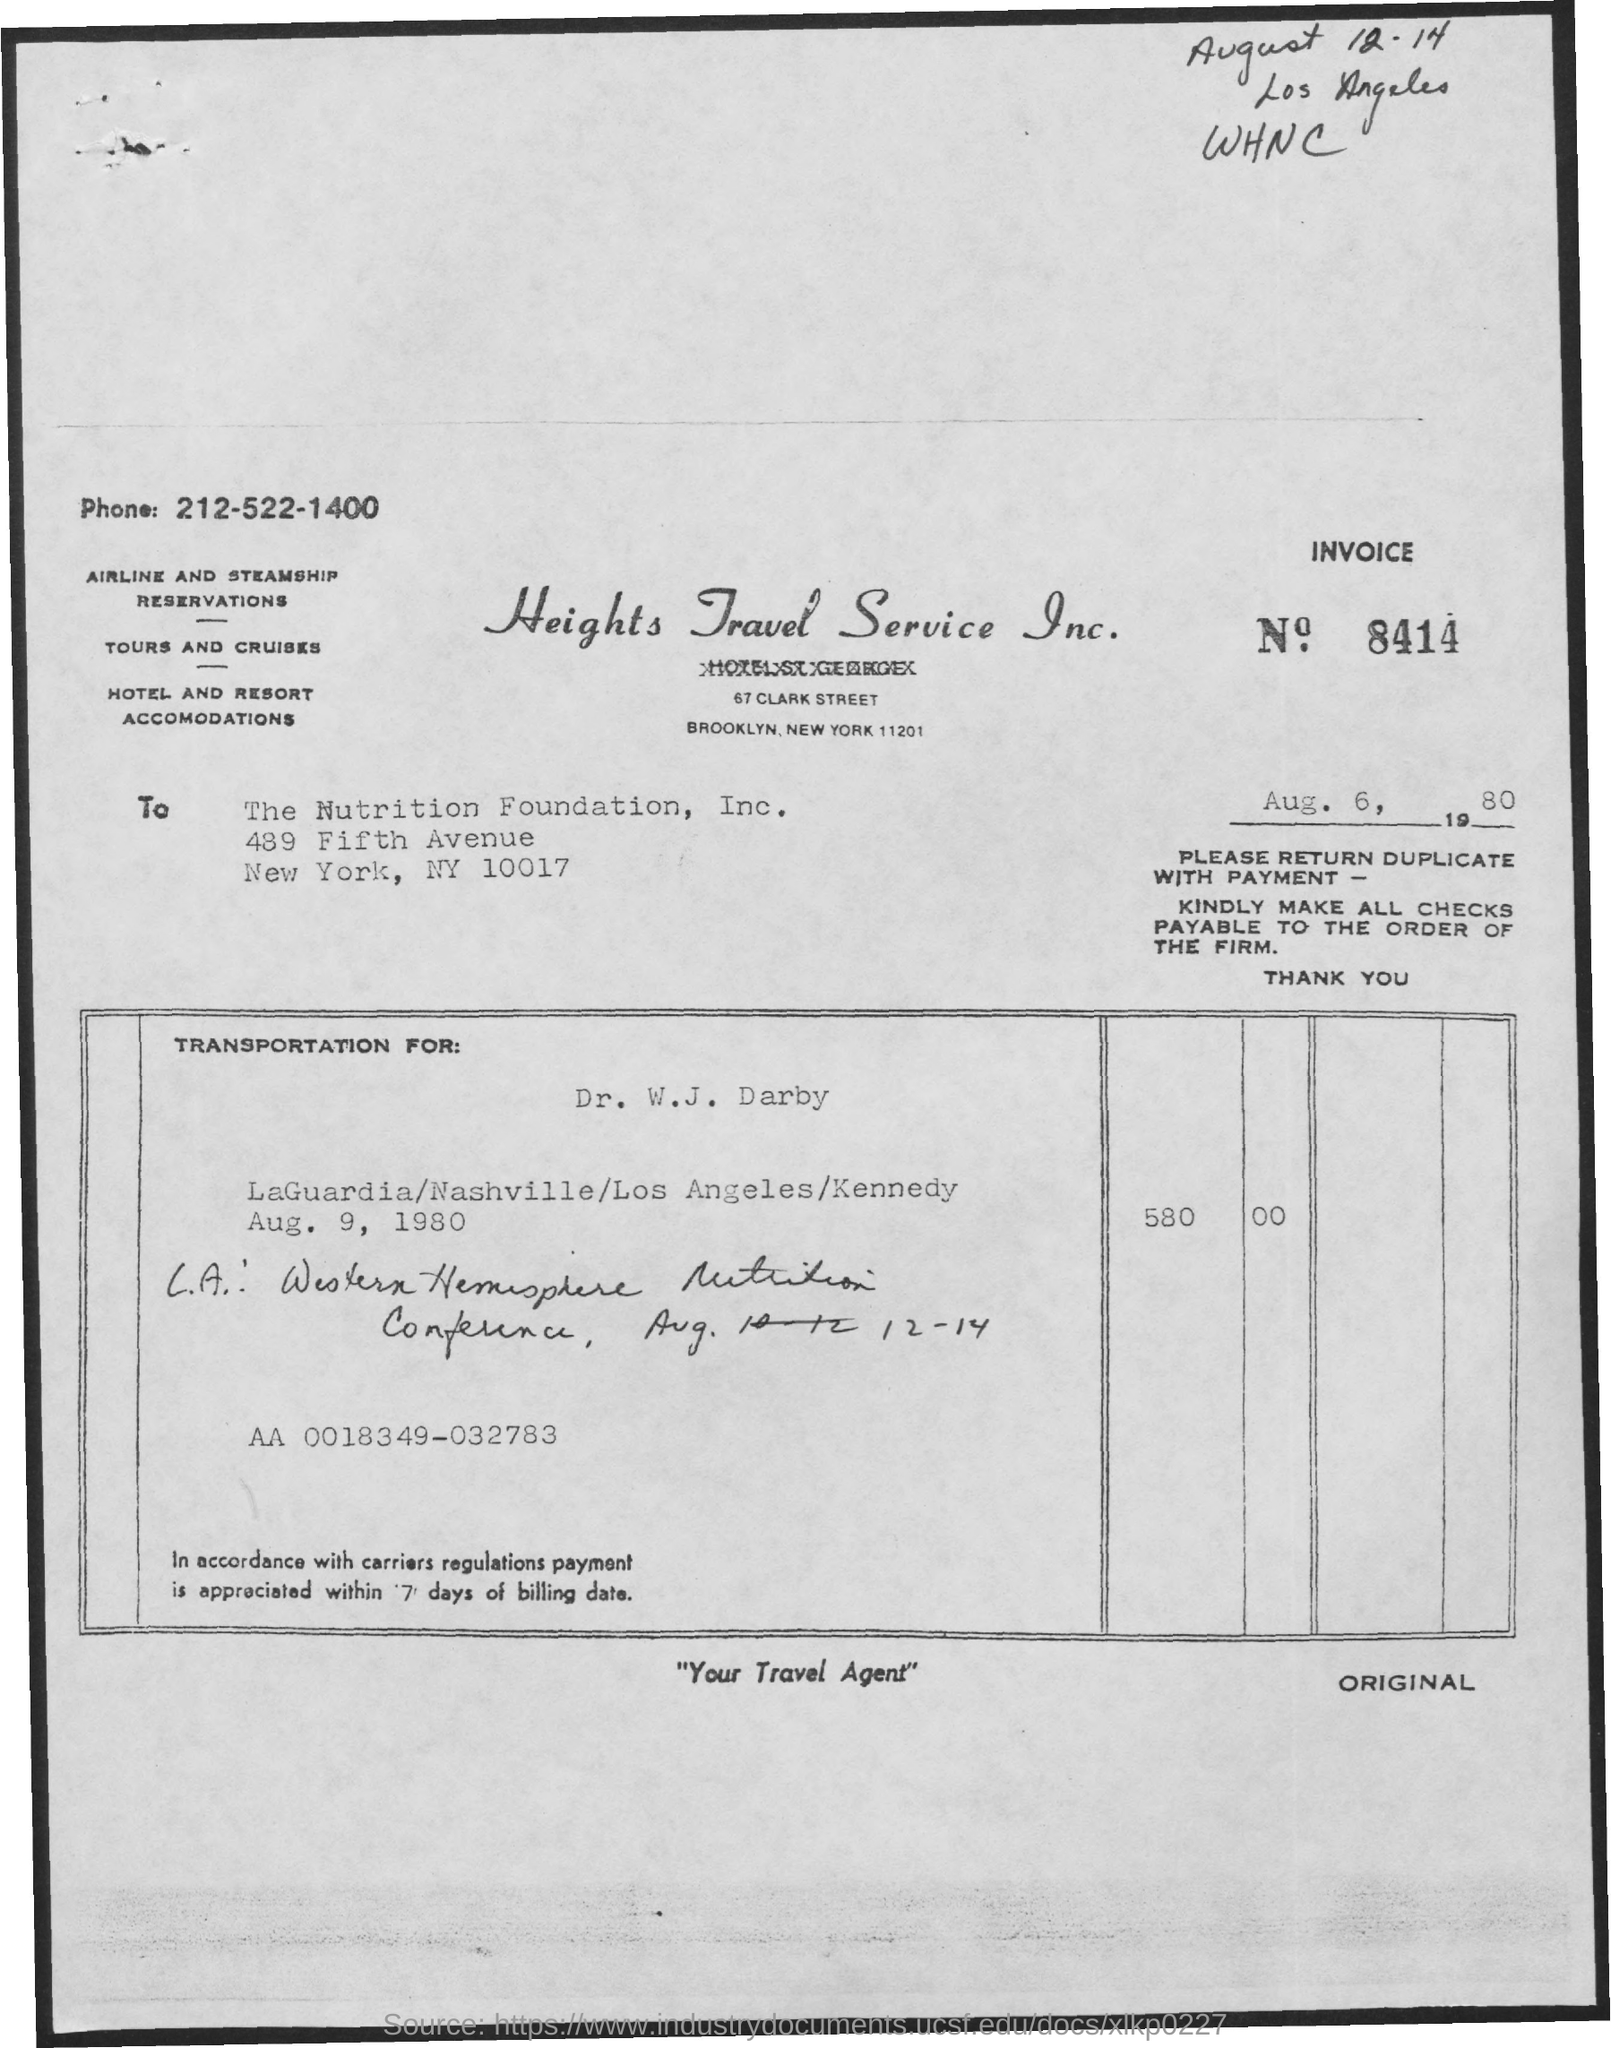Outline some significant characteristics in this image. The date listed below the invoice number is August 6, 1980. The invoice number is 8414. 